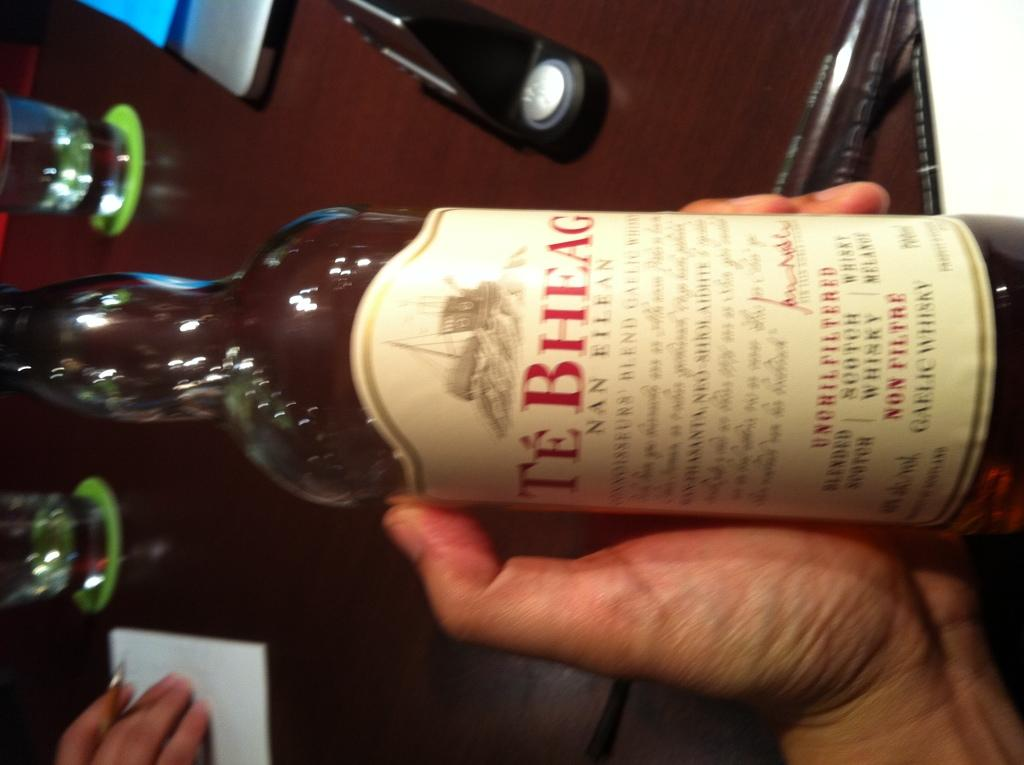<image>
Provide a brief description of the given image. Someone is holding a bottle of Te Bheag in their left hand. 